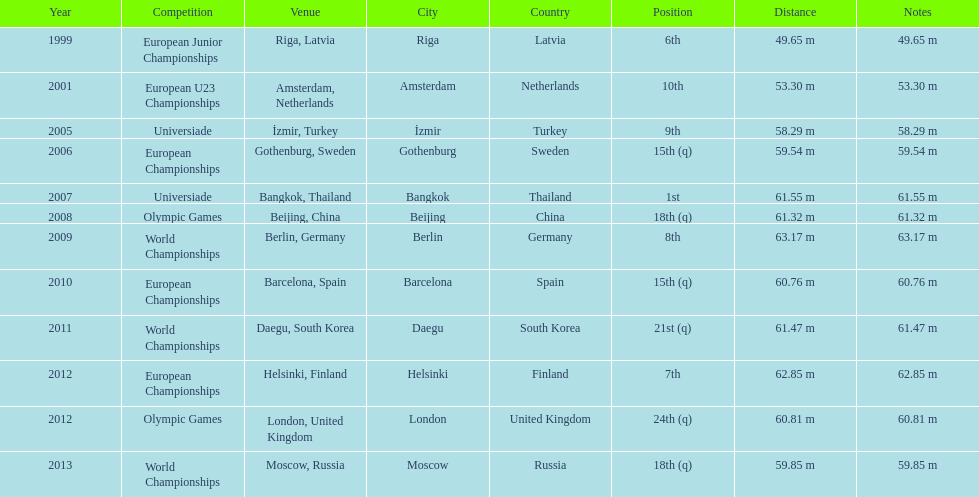What was the last competition he was in before the 2012 olympics? European Championships. 